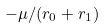<formula> <loc_0><loc_0><loc_500><loc_500>- \mu / ( r _ { 0 } + r _ { 1 } )</formula> 